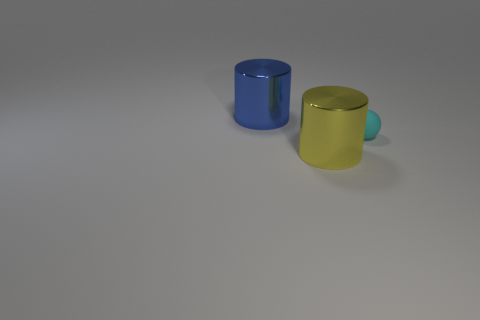There is another big object that is made of the same material as the yellow thing; what is its color?
Ensure brevity in your answer.  Blue. What number of green things are cylinders or matte cubes?
Ensure brevity in your answer.  0. What number of blue cylinders are the same size as the yellow thing?
Offer a terse response. 1. Does the big cylinder that is in front of the large blue object have the same material as the tiny cyan object?
Keep it short and to the point. No. There is a shiny cylinder behind the small sphere; are there any large things to the right of it?
Give a very brief answer. Yes. There is another thing that is the same shape as the yellow metal object; what is its material?
Offer a terse response. Metal. Is the number of metal cylinders behind the small cyan rubber ball greater than the number of yellow cylinders behind the big blue metal object?
Make the answer very short. Yes. What shape is the big blue thing that is made of the same material as the yellow cylinder?
Your answer should be very brief. Cylinder. Is the number of big blue things on the left side of the cyan matte sphere greater than the number of small gray objects?
Ensure brevity in your answer.  Yes. What number of other spheres are the same color as the sphere?
Keep it short and to the point. 0. 